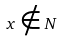Convert formula to latex. <formula><loc_0><loc_0><loc_500><loc_500>x \notin N</formula> 